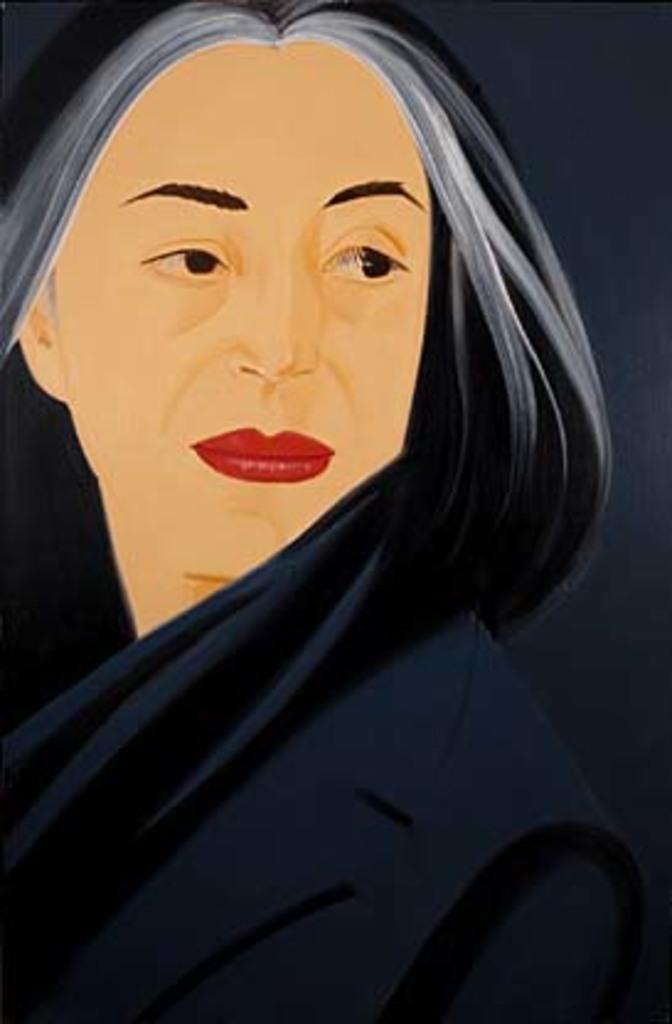What type of artwork is shown in the image? The image is a painting. What subject matter is depicted in the painting? The painting depicts a lady. What fictional character is pulling the lady in the painting? There is no character pulling the lady in the painting, as the image does not depict any fictional characters. 